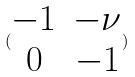Convert formula to latex. <formula><loc_0><loc_0><loc_500><loc_500>( \begin{matrix} - 1 & - \nu \\ 0 & - 1 \end{matrix} )</formula> 